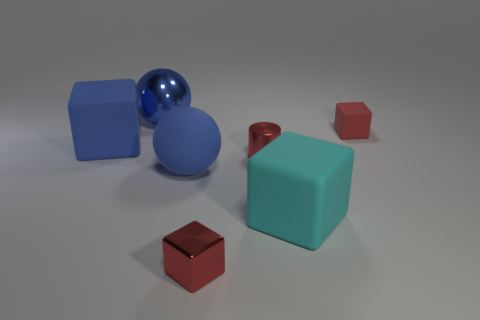Is the number of metallic objects greater than the number of matte objects?
Make the answer very short. No. There is a blue matte thing that is behind the tiny red cylinder; is its shape the same as the big blue metallic thing?
Provide a short and direct response. No. How many blocks are both behind the cyan matte cube and on the left side of the big cyan block?
Keep it short and to the point. 1. What number of red shiny things are the same shape as the large cyan object?
Ensure brevity in your answer.  1. There is a small shiny cube to the right of the cube on the left side of the tiny red shiny block; what is its color?
Offer a terse response. Red. Is the shape of the red rubber object the same as the thing in front of the cyan thing?
Your answer should be very brief. Yes. What material is the thing on the left side of the big ball behind the block that is left of the red shiny cube made of?
Offer a terse response. Rubber. Are there any blue things that have the same size as the blue rubber block?
Provide a succinct answer. Yes. What is the size of the cube that is the same material as the tiny cylinder?
Provide a short and direct response. Small. The large metallic thing has what shape?
Your answer should be very brief. Sphere. 